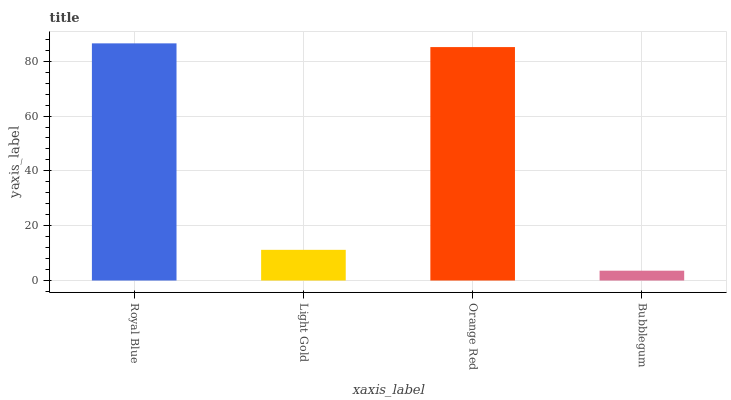Is Bubblegum the minimum?
Answer yes or no. Yes. Is Royal Blue the maximum?
Answer yes or no. Yes. Is Light Gold the minimum?
Answer yes or no. No. Is Light Gold the maximum?
Answer yes or no. No. Is Royal Blue greater than Light Gold?
Answer yes or no. Yes. Is Light Gold less than Royal Blue?
Answer yes or no. Yes. Is Light Gold greater than Royal Blue?
Answer yes or no. No. Is Royal Blue less than Light Gold?
Answer yes or no. No. Is Orange Red the high median?
Answer yes or no. Yes. Is Light Gold the low median?
Answer yes or no. Yes. Is Light Gold the high median?
Answer yes or no. No. Is Bubblegum the low median?
Answer yes or no. No. 